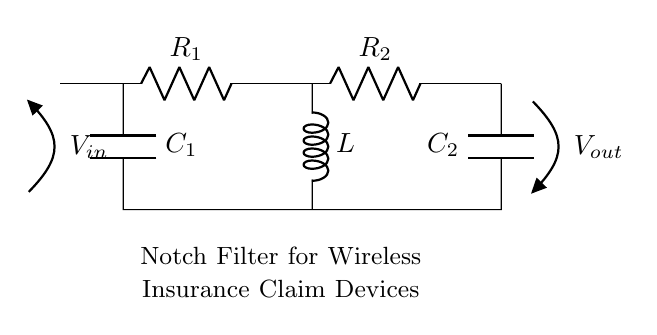What are the components of the notch filter circuit? The components visible in the circuit diagram are two resistors (R1 and R2), two capacitors (C1 and C2), and one inductor (L). Each component is clearly labeled, making it easy to identify them based on their symbols.
Answer: Two resistors, two capacitors, one inductor What is the input voltage labeled as? The input voltage is labeled as V-in, which is stated next to the open terminal on the left side of the circuit diagram. The labeling indicates the point where voltage enters the circuit.
Answer: V-in How many capacitors are present in the circuit? There are two capacitors shown in the diagram, represented by the symbols C1 and C2. The count is based on the visual representation of the components marked with the letter "C."
Answer: Two What is the role of the inductor in this filter circuit? The inductor in a notch filter circuit, like the one shown, is primarily used to create a specific frequency response that helps eliminate unwanted frequencies, or noise, from the signal. By analyzing its placement between two resistors, we understand its function in the filter design.
Answer: Eliminating unwanted frequencies What would be the effect of increasing the value of capacitor C1? Increasing the value of capacitor C1 would lower the resonant frequency of the notch filter, hence allowing more low-frequency signals to pass. This is because larger capacitors store more charge, affecting the impedance at a particular frequency.
Answer: Lower resonant frequency What can be inferred about the outflow voltage V-out? The outflow voltage V-out is depicted at the right side of the circuit and indicates the filtered output after interference reduction. Since this is a notch filter, the output voltage will have diminished levels of specific interfering frequencies.
Answer: Filtered output voltage How does the configuration of R1 and R2 affect the filter's performance? The configuration of R1 and R2 influences the overall gain and impedance seen by the signal. In a notch filter, these resistors set the attenuation level and affect the shape of the frequency response, which determines the effectiveness of interference rejection.
Answer: Affects gain and frequency response 